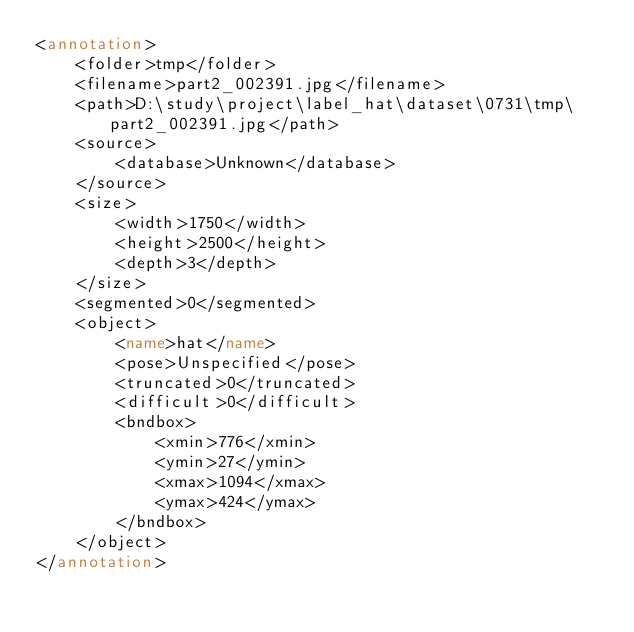<code> <loc_0><loc_0><loc_500><loc_500><_XML_><annotation>
	<folder>tmp</folder>
	<filename>part2_002391.jpg</filename>
	<path>D:\study\project\label_hat\dataset\0731\tmp\part2_002391.jpg</path>
	<source>
		<database>Unknown</database>
	</source>
	<size>
		<width>1750</width>
		<height>2500</height>
		<depth>3</depth>
	</size>
	<segmented>0</segmented>
	<object>
		<name>hat</name>
		<pose>Unspecified</pose>
		<truncated>0</truncated>
		<difficult>0</difficult>
		<bndbox>
			<xmin>776</xmin>
			<ymin>27</ymin>
			<xmax>1094</xmax>
			<ymax>424</ymax>
		</bndbox>
	</object>
</annotation>
</code> 